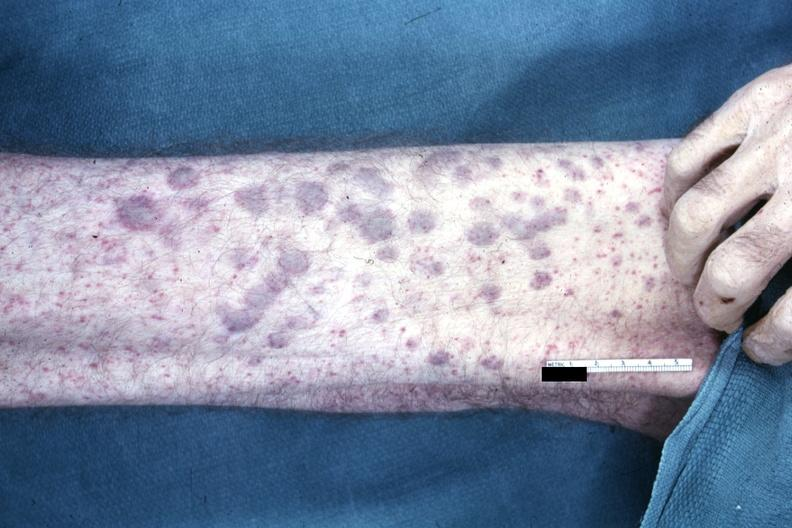s not best color rendition showing elevated macular lesions on arm said to be aml infiltrates?
Answer the question using a single word or phrase. Yes 